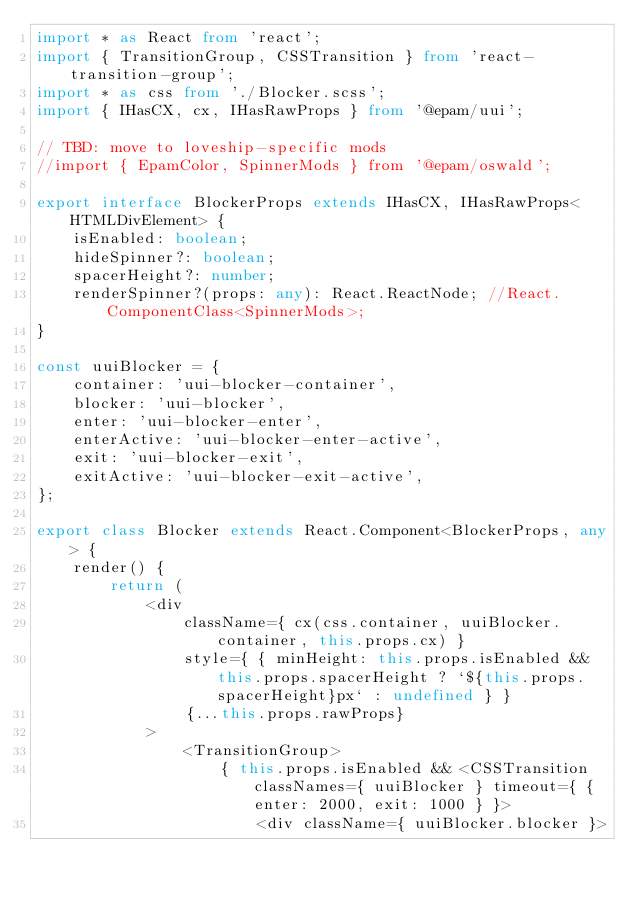Convert code to text. <code><loc_0><loc_0><loc_500><loc_500><_TypeScript_>import * as React from 'react';
import { TransitionGroup, CSSTransition } from 'react-transition-group';
import * as css from './Blocker.scss';
import { IHasCX, cx, IHasRawProps } from '@epam/uui';

// TBD: move to loveship-specific mods
//import { EpamColor, SpinnerMods } from '@epam/oswald';

export interface BlockerProps extends IHasCX, IHasRawProps<HTMLDivElement> {
    isEnabled: boolean;
    hideSpinner?: boolean;
    spacerHeight?: number;
    renderSpinner?(props: any): React.ReactNode; //React.ComponentClass<SpinnerMods>;
}

const uuiBlocker = {
    container: 'uui-blocker-container',
    blocker: 'uui-blocker',
    enter: 'uui-blocker-enter',
    enterActive: 'uui-blocker-enter-active',
    exit: 'uui-blocker-exit',
    exitActive: 'uui-blocker-exit-active',
};

export class Blocker extends React.Component<BlockerProps, any> {
    render() {
        return (
            <div
                className={ cx(css.container, uuiBlocker.container, this.props.cx) }
                style={ { minHeight: this.props.isEnabled && this.props.spacerHeight ? `${this.props.spacerHeight}px` : undefined } }
                {...this.props.rawProps}
            >
                <TransitionGroup>
                    { this.props.isEnabled && <CSSTransition classNames={ uuiBlocker } timeout={ { enter: 2000, exit: 1000 } }>
                        <div className={ uuiBlocker.blocker }></code> 